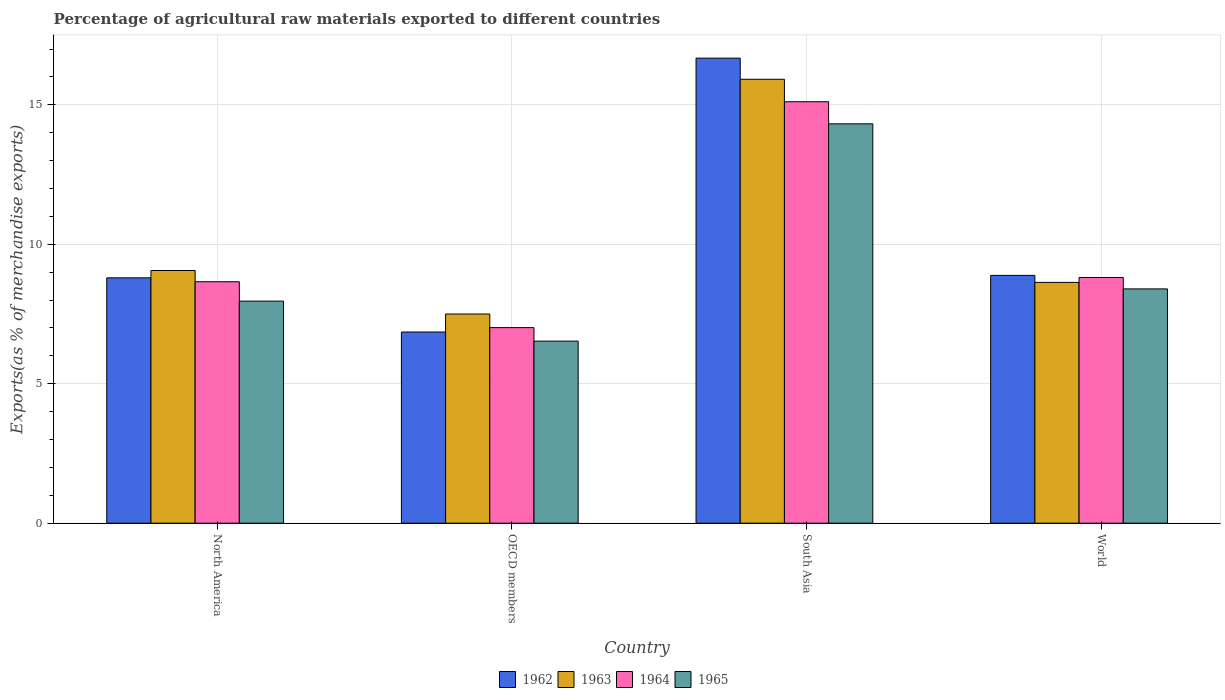How many different coloured bars are there?
Give a very brief answer. 4. Are the number of bars per tick equal to the number of legend labels?
Keep it short and to the point. Yes. Are the number of bars on each tick of the X-axis equal?
Offer a terse response. Yes. What is the label of the 4th group of bars from the left?
Keep it short and to the point. World. What is the percentage of exports to different countries in 1962 in North America?
Provide a short and direct response. 8.8. Across all countries, what is the maximum percentage of exports to different countries in 1965?
Provide a succinct answer. 14.32. Across all countries, what is the minimum percentage of exports to different countries in 1964?
Offer a very short reply. 7.01. In which country was the percentage of exports to different countries in 1965 maximum?
Your answer should be very brief. South Asia. In which country was the percentage of exports to different countries in 1962 minimum?
Your answer should be very brief. OECD members. What is the total percentage of exports to different countries in 1964 in the graph?
Your response must be concise. 39.59. What is the difference between the percentage of exports to different countries in 1963 in OECD members and that in World?
Ensure brevity in your answer.  -1.13. What is the difference between the percentage of exports to different countries in 1962 in South Asia and the percentage of exports to different countries in 1963 in North America?
Your answer should be very brief. 7.61. What is the average percentage of exports to different countries in 1964 per country?
Make the answer very short. 9.9. What is the difference between the percentage of exports to different countries of/in 1964 and percentage of exports to different countries of/in 1963 in OECD members?
Ensure brevity in your answer.  -0.49. What is the ratio of the percentage of exports to different countries in 1963 in North America to that in South Asia?
Your response must be concise. 0.57. Is the difference between the percentage of exports to different countries in 1964 in OECD members and South Asia greater than the difference between the percentage of exports to different countries in 1963 in OECD members and South Asia?
Keep it short and to the point. Yes. What is the difference between the highest and the second highest percentage of exports to different countries in 1963?
Provide a succinct answer. -0.43. What is the difference between the highest and the lowest percentage of exports to different countries in 1963?
Your response must be concise. 8.42. In how many countries, is the percentage of exports to different countries in 1965 greater than the average percentage of exports to different countries in 1965 taken over all countries?
Make the answer very short. 1. Is the sum of the percentage of exports to different countries in 1962 in North America and World greater than the maximum percentage of exports to different countries in 1963 across all countries?
Ensure brevity in your answer.  Yes. What does the 4th bar from the right in OECD members represents?
Your response must be concise. 1962. Is it the case that in every country, the sum of the percentage of exports to different countries in 1965 and percentage of exports to different countries in 1962 is greater than the percentage of exports to different countries in 1964?
Provide a succinct answer. Yes. Are all the bars in the graph horizontal?
Provide a succinct answer. No. How many countries are there in the graph?
Your answer should be very brief. 4. Are the values on the major ticks of Y-axis written in scientific E-notation?
Your answer should be compact. No. Does the graph contain grids?
Provide a short and direct response. Yes. How are the legend labels stacked?
Ensure brevity in your answer.  Horizontal. What is the title of the graph?
Ensure brevity in your answer.  Percentage of agricultural raw materials exported to different countries. Does "1978" appear as one of the legend labels in the graph?
Your answer should be very brief. No. What is the label or title of the Y-axis?
Make the answer very short. Exports(as % of merchandise exports). What is the Exports(as % of merchandise exports) of 1962 in North America?
Give a very brief answer. 8.8. What is the Exports(as % of merchandise exports) in 1963 in North America?
Ensure brevity in your answer.  9.06. What is the Exports(as % of merchandise exports) of 1964 in North America?
Ensure brevity in your answer.  8.66. What is the Exports(as % of merchandise exports) of 1965 in North America?
Make the answer very short. 7.96. What is the Exports(as % of merchandise exports) in 1962 in OECD members?
Give a very brief answer. 6.85. What is the Exports(as % of merchandise exports) in 1963 in OECD members?
Ensure brevity in your answer.  7.5. What is the Exports(as % of merchandise exports) in 1964 in OECD members?
Ensure brevity in your answer.  7.01. What is the Exports(as % of merchandise exports) in 1965 in OECD members?
Ensure brevity in your answer.  6.53. What is the Exports(as % of merchandise exports) in 1962 in South Asia?
Offer a terse response. 16.67. What is the Exports(as % of merchandise exports) in 1963 in South Asia?
Make the answer very short. 15.92. What is the Exports(as % of merchandise exports) in 1964 in South Asia?
Your answer should be compact. 15.11. What is the Exports(as % of merchandise exports) in 1965 in South Asia?
Provide a short and direct response. 14.32. What is the Exports(as % of merchandise exports) in 1962 in World?
Your answer should be very brief. 8.89. What is the Exports(as % of merchandise exports) of 1963 in World?
Provide a short and direct response. 8.63. What is the Exports(as % of merchandise exports) in 1964 in World?
Make the answer very short. 8.81. What is the Exports(as % of merchandise exports) of 1965 in World?
Your answer should be compact. 8.4. Across all countries, what is the maximum Exports(as % of merchandise exports) in 1962?
Give a very brief answer. 16.67. Across all countries, what is the maximum Exports(as % of merchandise exports) in 1963?
Keep it short and to the point. 15.92. Across all countries, what is the maximum Exports(as % of merchandise exports) of 1964?
Keep it short and to the point. 15.11. Across all countries, what is the maximum Exports(as % of merchandise exports) in 1965?
Offer a terse response. 14.32. Across all countries, what is the minimum Exports(as % of merchandise exports) of 1962?
Your answer should be very brief. 6.85. Across all countries, what is the minimum Exports(as % of merchandise exports) in 1963?
Make the answer very short. 7.5. Across all countries, what is the minimum Exports(as % of merchandise exports) of 1964?
Give a very brief answer. 7.01. Across all countries, what is the minimum Exports(as % of merchandise exports) in 1965?
Ensure brevity in your answer.  6.53. What is the total Exports(as % of merchandise exports) of 1962 in the graph?
Ensure brevity in your answer.  41.21. What is the total Exports(as % of merchandise exports) of 1963 in the graph?
Make the answer very short. 41.11. What is the total Exports(as % of merchandise exports) in 1964 in the graph?
Keep it short and to the point. 39.59. What is the total Exports(as % of merchandise exports) of 1965 in the graph?
Offer a terse response. 37.21. What is the difference between the Exports(as % of merchandise exports) in 1962 in North America and that in OECD members?
Ensure brevity in your answer.  1.94. What is the difference between the Exports(as % of merchandise exports) in 1963 in North America and that in OECD members?
Your response must be concise. 1.56. What is the difference between the Exports(as % of merchandise exports) in 1964 in North America and that in OECD members?
Keep it short and to the point. 1.65. What is the difference between the Exports(as % of merchandise exports) of 1965 in North America and that in OECD members?
Give a very brief answer. 1.43. What is the difference between the Exports(as % of merchandise exports) in 1962 in North America and that in South Asia?
Your response must be concise. -7.88. What is the difference between the Exports(as % of merchandise exports) of 1963 in North America and that in South Asia?
Your answer should be very brief. -6.86. What is the difference between the Exports(as % of merchandise exports) of 1964 in North America and that in South Asia?
Give a very brief answer. -6.45. What is the difference between the Exports(as % of merchandise exports) of 1965 in North America and that in South Asia?
Your answer should be very brief. -6.36. What is the difference between the Exports(as % of merchandise exports) in 1962 in North America and that in World?
Offer a very short reply. -0.09. What is the difference between the Exports(as % of merchandise exports) of 1963 in North America and that in World?
Provide a short and direct response. 0.43. What is the difference between the Exports(as % of merchandise exports) of 1964 in North America and that in World?
Keep it short and to the point. -0.15. What is the difference between the Exports(as % of merchandise exports) of 1965 in North America and that in World?
Keep it short and to the point. -0.44. What is the difference between the Exports(as % of merchandise exports) in 1962 in OECD members and that in South Asia?
Your response must be concise. -9.82. What is the difference between the Exports(as % of merchandise exports) of 1963 in OECD members and that in South Asia?
Your answer should be very brief. -8.42. What is the difference between the Exports(as % of merchandise exports) in 1964 in OECD members and that in South Asia?
Provide a succinct answer. -8.1. What is the difference between the Exports(as % of merchandise exports) of 1965 in OECD members and that in South Asia?
Ensure brevity in your answer.  -7.79. What is the difference between the Exports(as % of merchandise exports) of 1962 in OECD members and that in World?
Ensure brevity in your answer.  -2.03. What is the difference between the Exports(as % of merchandise exports) in 1963 in OECD members and that in World?
Offer a very short reply. -1.13. What is the difference between the Exports(as % of merchandise exports) in 1964 in OECD members and that in World?
Make the answer very short. -1.8. What is the difference between the Exports(as % of merchandise exports) of 1965 in OECD members and that in World?
Your answer should be very brief. -1.87. What is the difference between the Exports(as % of merchandise exports) of 1962 in South Asia and that in World?
Make the answer very short. 7.79. What is the difference between the Exports(as % of merchandise exports) in 1963 in South Asia and that in World?
Your answer should be very brief. 7.28. What is the difference between the Exports(as % of merchandise exports) in 1964 in South Asia and that in World?
Ensure brevity in your answer.  6.3. What is the difference between the Exports(as % of merchandise exports) in 1965 in South Asia and that in World?
Offer a terse response. 5.92. What is the difference between the Exports(as % of merchandise exports) in 1962 in North America and the Exports(as % of merchandise exports) in 1963 in OECD members?
Keep it short and to the point. 1.3. What is the difference between the Exports(as % of merchandise exports) in 1962 in North America and the Exports(as % of merchandise exports) in 1964 in OECD members?
Provide a short and direct response. 1.78. What is the difference between the Exports(as % of merchandise exports) in 1962 in North America and the Exports(as % of merchandise exports) in 1965 in OECD members?
Give a very brief answer. 2.27. What is the difference between the Exports(as % of merchandise exports) of 1963 in North America and the Exports(as % of merchandise exports) of 1964 in OECD members?
Offer a very short reply. 2.05. What is the difference between the Exports(as % of merchandise exports) of 1963 in North America and the Exports(as % of merchandise exports) of 1965 in OECD members?
Ensure brevity in your answer.  2.53. What is the difference between the Exports(as % of merchandise exports) of 1964 in North America and the Exports(as % of merchandise exports) of 1965 in OECD members?
Provide a succinct answer. 2.13. What is the difference between the Exports(as % of merchandise exports) of 1962 in North America and the Exports(as % of merchandise exports) of 1963 in South Asia?
Ensure brevity in your answer.  -7.12. What is the difference between the Exports(as % of merchandise exports) in 1962 in North America and the Exports(as % of merchandise exports) in 1964 in South Asia?
Offer a very short reply. -6.31. What is the difference between the Exports(as % of merchandise exports) of 1962 in North America and the Exports(as % of merchandise exports) of 1965 in South Asia?
Provide a succinct answer. -5.52. What is the difference between the Exports(as % of merchandise exports) in 1963 in North America and the Exports(as % of merchandise exports) in 1964 in South Asia?
Make the answer very short. -6.05. What is the difference between the Exports(as % of merchandise exports) in 1963 in North America and the Exports(as % of merchandise exports) in 1965 in South Asia?
Offer a very short reply. -5.26. What is the difference between the Exports(as % of merchandise exports) in 1964 in North America and the Exports(as % of merchandise exports) in 1965 in South Asia?
Give a very brief answer. -5.66. What is the difference between the Exports(as % of merchandise exports) in 1962 in North America and the Exports(as % of merchandise exports) in 1963 in World?
Offer a terse response. 0.16. What is the difference between the Exports(as % of merchandise exports) in 1962 in North America and the Exports(as % of merchandise exports) in 1964 in World?
Provide a short and direct response. -0.01. What is the difference between the Exports(as % of merchandise exports) of 1962 in North America and the Exports(as % of merchandise exports) of 1965 in World?
Ensure brevity in your answer.  0.4. What is the difference between the Exports(as % of merchandise exports) of 1963 in North America and the Exports(as % of merchandise exports) of 1964 in World?
Your response must be concise. 0.25. What is the difference between the Exports(as % of merchandise exports) in 1963 in North America and the Exports(as % of merchandise exports) in 1965 in World?
Ensure brevity in your answer.  0.66. What is the difference between the Exports(as % of merchandise exports) of 1964 in North America and the Exports(as % of merchandise exports) of 1965 in World?
Your answer should be compact. 0.26. What is the difference between the Exports(as % of merchandise exports) in 1962 in OECD members and the Exports(as % of merchandise exports) in 1963 in South Asia?
Your response must be concise. -9.06. What is the difference between the Exports(as % of merchandise exports) in 1962 in OECD members and the Exports(as % of merchandise exports) in 1964 in South Asia?
Ensure brevity in your answer.  -8.26. What is the difference between the Exports(as % of merchandise exports) in 1962 in OECD members and the Exports(as % of merchandise exports) in 1965 in South Asia?
Keep it short and to the point. -7.46. What is the difference between the Exports(as % of merchandise exports) of 1963 in OECD members and the Exports(as % of merchandise exports) of 1964 in South Asia?
Give a very brief answer. -7.61. What is the difference between the Exports(as % of merchandise exports) in 1963 in OECD members and the Exports(as % of merchandise exports) in 1965 in South Asia?
Make the answer very short. -6.82. What is the difference between the Exports(as % of merchandise exports) in 1964 in OECD members and the Exports(as % of merchandise exports) in 1965 in South Asia?
Offer a very short reply. -7.31. What is the difference between the Exports(as % of merchandise exports) in 1962 in OECD members and the Exports(as % of merchandise exports) in 1963 in World?
Offer a terse response. -1.78. What is the difference between the Exports(as % of merchandise exports) of 1962 in OECD members and the Exports(as % of merchandise exports) of 1964 in World?
Provide a short and direct response. -1.95. What is the difference between the Exports(as % of merchandise exports) of 1962 in OECD members and the Exports(as % of merchandise exports) of 1965 in World?
Your response must be concise. -1.55. What is the difference between the Exports(as % of merchandise exports) of 1963 in OECD members and the Exports(as % of merchandise exports) of 1964 in World?
Make the answer very short. -1.31. What is the difference between the Exports(as % of merchandise exports) in 1963 in OECD members and the Exports(as % of merchandise exports) in 1965 in World?
Offer a very short reply. -0.9. What is the difference between the Exports(as % of merchandise exports) in 1964 in OECD members and the Exports(as % of merchandise exports) in 1965 in World?
Offer a very short reply. -1.39. What is the difference between the Exports(as % of merchandise exports) of 1962 in South Asia and the Exports(as % of merchandise exports) of 1963 in World?
Your answer should be very brief. 8.04. What is the difference between the Exports(as % of merchandise exports) in 1962 in South Asia and the Exports(as % of merchandise exports) in 1964 in World?
Give a very brief answer. 7.87. What is the difference between the Exports(as % of merchandise exports) in 1962 in South Asia and the Exports(as % of merchandise exports) in 1965 in World?
Give a very brief answer. 8.27. What is the difference between the Exports(as % of merchandise exports) in 1963 in South Asia and the Exports(as % of merchandise exports) in 1964 in World?
Your response must be concise. 7.11. What is the difference between the Exports(as % of merchandise exports) in 1963 in South Asia and the Exports(as % of merchandise exports) in 1965 in World?
Provide a short and direct response. 7.52. What is the difference between the Exports(as % of merchandise exports) in 1964 in South Asia and the Exports(as % of merchandise exports) in 1965 in World?
Offer a terse response. 6.71. What is the average Exports(as % of merchandise exports) of 1962 per country?
Ensure brevity in your answer.  10.3. What is the average Exports(as % of merchandise exports) of 1963 per country?
Provide a short and direct response. 10.28. What is the average Exports(as % of merchandise exports) of 1964 per country?
Give a very brief answer. 9.9. What is the average Exports(as % of merchandise exports) in 1965 per country?
Your answer should be compact. 9.3. What is the difference between the Exports(as % of merchandise exports) in 1962 and Exports(as % of merchandise exports) in 1963 in North America?
Your response must be concise. -0.26. What is the difference between the Exports(as % of merchandise exports) of 1962 and Exports(as % of merchandise exports) of 1964 in North America?
Provide a short and direct response. 0.14. What is the difference between the Exports(as % of merchandise exports) of 1962 and Exports(as % of merchandise exports) of 1965 in North America?
Provide a short and direct response. 0.83. What is the difference between the Exports(as % of merchandise exports) in 1963 and Exports(as % of merchandise exports) in 1964 in North America?
Make the answer very short. 0.4. What is the difference between the Exports(as % of merchandise exports) in 1963 and Exports(as % of merchandise exports) in 1965 in North America?
Keep it short and to the point. 1.1. What is the difference between the Exports(as % of merchandise exports) in 1964 and Exports(as % of merchandise exports) in 1965 in North America?
Keep it short and to the point. 0.69. What is the difference between the Exports(as % of merchandise exports) in 1962 and Exports(as % of merchandise exports) in 1963 in OECD members?
Your response must be concise. -0.65. What is the difference between the Exports(as % of merchandise exports) of 1962 and Exports(as % of merchandise exports) of 1964 in OECD members?
Ensure brevity in your answer.  -0.16. What is the difference between the Exports(as % of merchandise exports) of 1962 and Exports(as % of merchandise exports) of 1965 in OECD members?
Make the answer very short. 0.33. What is the difference between the Exports(as % of merchandise exports) of 1963 and Exports(as % of merchandise exports) of 1964 in OECD members?
Ensure brevity in your answer.  0.49. What is the difference between the Exports(as % of merchandise exports) of 1963 and Exports(as % of merchandise exports) of 1965 in OECD members?
Your answer should be compact. 0.97. What is the difference between the Exports(as % of merchandise exports) of 1964 and Exports(as % of merchandise exports) of 1965 in OECD members?
Your answer should be very brief. 0.48. What is the difference between the Exports(as % of merchandise exports) in 1962 and Exports(as % of merchandise exports) in 1963 in South Asia?
Your response must be concise. 0.76. What is the difference between the Exports(as % of merchandise exports) in 1962 and Exports(as % of merchandise exports) in 1964 in South Asia?
Make the answer very short. 1.56. What is the difference between the Exports(as % of merchandise exports) in 1962 and Exports(as % of merchandise exports) in 1965 in South Asia?
Your answer should be compact. 2.36. What is the difference between the Exports(as % of merchandise exports) in 1963 and Exports(as % of merchandise exports) in 1964 in South Asia?
Your answer should be compact. 0.81. What is the difference between the Exports(as % of merchandise exports) in 1963 and Exports(as % of merchandise exports) in 1965 in South Asia?
Your answer should be very brief. 1.6. What is the difference between the Exports(as % of merchandise exports) of 1964 and Exports(as % of merchandise exports) of 1965 in South Asia?
Provide a succinct answer. 0.79. What is the difference between the Exports(as % of merchandise exports) in 1962 and Exports(as % of merchandise exports) in 1963 in World?
Offer a very short reply. 0.25. What is the difference between the Exports(as % of merchandise exports) in 1962 and Exports(as % of merchandise exports) in 1964 in World?
Offer a very short reply. 0.08. What is the difference between the Exports(as % of merchandise exports) in 1962 and Exports(as % of merchandise exports) in 1965 in World?
Your answer should be compact. 0.48. What is the difference between the Exports(as % of merchandise exports) of 1963 and Exports(as % of merchandise exports) of 1964 in World?
Give a very brief answer. -0.18. What is the difference between the Exports(as % of merchandise exports) in 1963 and Exports(as % of merchandise exports) in 1965 in World?
Your response must be concise. 0.23. What is the difference between the Exports(as % of merchandise exports) of 1964 and Exports(as % of merchandise exports) of 1965 in World?
Ensure brevity in your answer.  0.41. What is the ratio of the Exports(as % of merchandise exports) of 1962 in North America to that in OECD members?
Offer a very short reply. 1.28. What is the ratio of the Exports(as % of merchandise exports) of 1963 in North America to that in OECD members?
Your answer should be very brief. 1.21. What is the ratio of the Exports(as % of merchandise exports) of 1964 in North America to that in OECD members?
Offer a very short reply. 1.23. What is the ratio of the Exports(as % of merchandise exports) in 1965 in North America to that in OECD members?
Ensure brevity in your answer.  1.22. What is the ratio of the Exports(as % of merchandise exports) of 1962 in North America to that in South Asia?
Give a very brief answer. 0.53. What is the ratio of the Exports(as % of merchandise exports) in 1963 in North America to that in South Asia?
Your answer should be compact. 0.57. What is the ratio of the Exports(as % of merchandise exports) of 1964 in North America to that in South Asia?
Your answer should be compact. 0.57. What is the ratio of the Exports(as % of merchandise exports) in 1965 in North America to that in South Asia?
Provide a short and direct response. 0.56. What is the ratio of the Exports(as % of merchandise exports) of 1962 in North America to that in World?
Your answer should be compact. 0.99. What is the ratio of the Exports(as % of merchandise exports) of 1963 in North America to that in World?
Give a very brief answer. 1.05. What is the ratio of the Exports(as % of merchandise exports) in 1964 in North America to that in World?
Your answer should be compact. 0.98. What is the ratio of the Exports(as % of merchandise exports) in 1965 in North America to that in World?
Make the answer very short. 0.95. What is the ratio of the Exports(as % of merchandise exports) in 1962 in OECD members to that in South Asia?
Keep it short and to the point. 0.41. What is the ratio of the Exports(as % of merchandise exports) in 1963 in OECD members to that in South Asia?
Provide a succinct answer. 0.47. What is the ratio of the Exports(as % of merchandise exports) in 1964 in OECD members to that in South Asia?
Offer a very short reply. 0.46. What is the ratio of the Exports(as % of merchandise exports) in 1965 in OECD members to that in South Asia?
Offer a very short reply. 0.46. What is the ratio of the Exports(as % of merchandise exports) of 1962 in OECD members to that in World?
Your answer should be compact. 0.77. What is the ratio of the Exports(as % of merchandise exports) in 1963 in OECD members to that in World?
Offer a very short reply. 0.87. What is the ratio of the Exports(as % of merchandise exports) in 1964 in OECD members to that in World?
Your answer should be very brief. 0.8. What is the ratio of the Exports(as % of merchandise exports) in 1965 in OECD members to that in World?
Offer a very short reply. 0.78. What is the ratio of the Exports(as % of merchandise exports) of 1962 in South Asia to that in World?
Your answer should be compact. 1.88. What is the ratio of the Exports(as % of merchandise exports) of 1963 in South Asia to that in World?
Your response must be concise. 1.84. What is the ratio of the Exports(as % of merchandise exports) of 1964 in South Asia to that in World?
Ensure brevity in your answer.  1.72. What is the ratio of the Exports(as % of merchandise exports) of 1965 in South Asia to that in World?
Ensure brevity in your answer.  1.7. What is the difference between the highest and the second highest Exports(as % of merchandise exports) of 1962?
Keep it short and to the point. 7.79. What is the difference between the highest and the second highest Exports(as % of merchandise exports) of 1963?
Your answer should be very brief. 6.86. What is the difference between the highest and the second highest Exports(as % of merchandise exports) in 1964?
Offer a very short reply. 6.3. What is the difference between the highest and the second highest Exports(as % of merchandise exports) in 1965?
Offer a terse response. 5.92. What is the difference between the highest and the lowest Exports(as % of merchandise exports) of 1962?
Your answer should be very brief. 9.82. What is the difference between the highest and the lowest Exports(as % of merchandise exports) in 1963?
Your answer should be very brief. 8.42. What is the difference between the highest and the lowest Exports(as % of merchandise exports) of 1964?
Keep it short and to the point. 8.1. What is the difference between the highest and the lowest Exports(as % of merchandise exports) of 1965?
Provide a short and direct response. 7.79. 